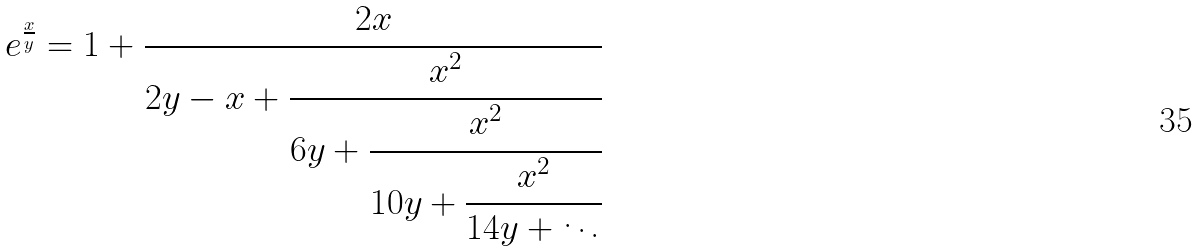<formula> <loc_0><loc_0><loc_500><loc_500>e ^ { \frac { x } { y } } = 1 + { \cfrac { 2 x } { 2 y - x + { \cfrac { x ^ { 2 } } { 6 y + { \cfrac { x ^ { 2 } } { 1 0 y + { \cfrac { x ^ { 2 } } { 1 4 y + \ddots } } } } } } } }</formula> 